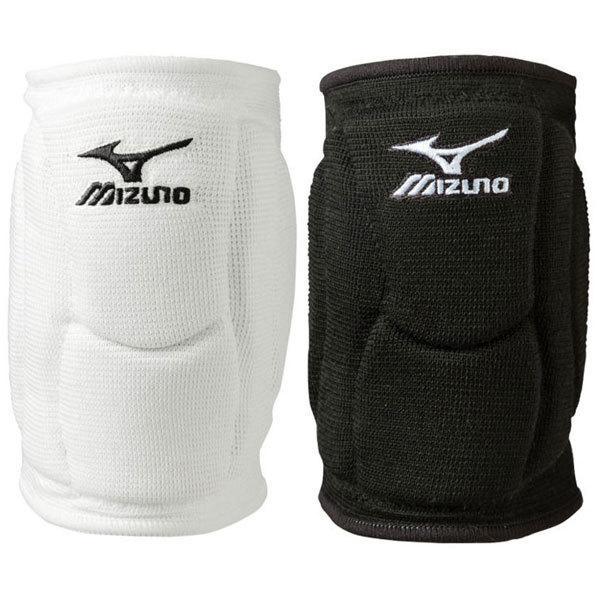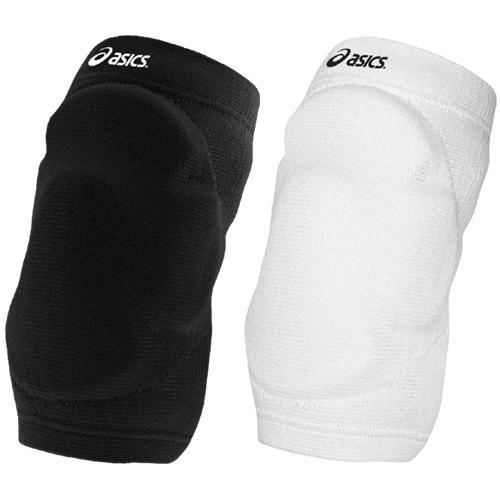The first image is the image on the left, the second image is the image on the right. For the images displayed, is the sentence "The right image contains exactly two black knee pads." factually correct? Answer yes or no. No. The first image is the image on the left, the second image is the image on the right. Evaluate the accuracy of this statement regarding the images: "A white kneepad is next to a black kneepad in at least one of the images.". Is it true? Answer yes or no. Yes. 